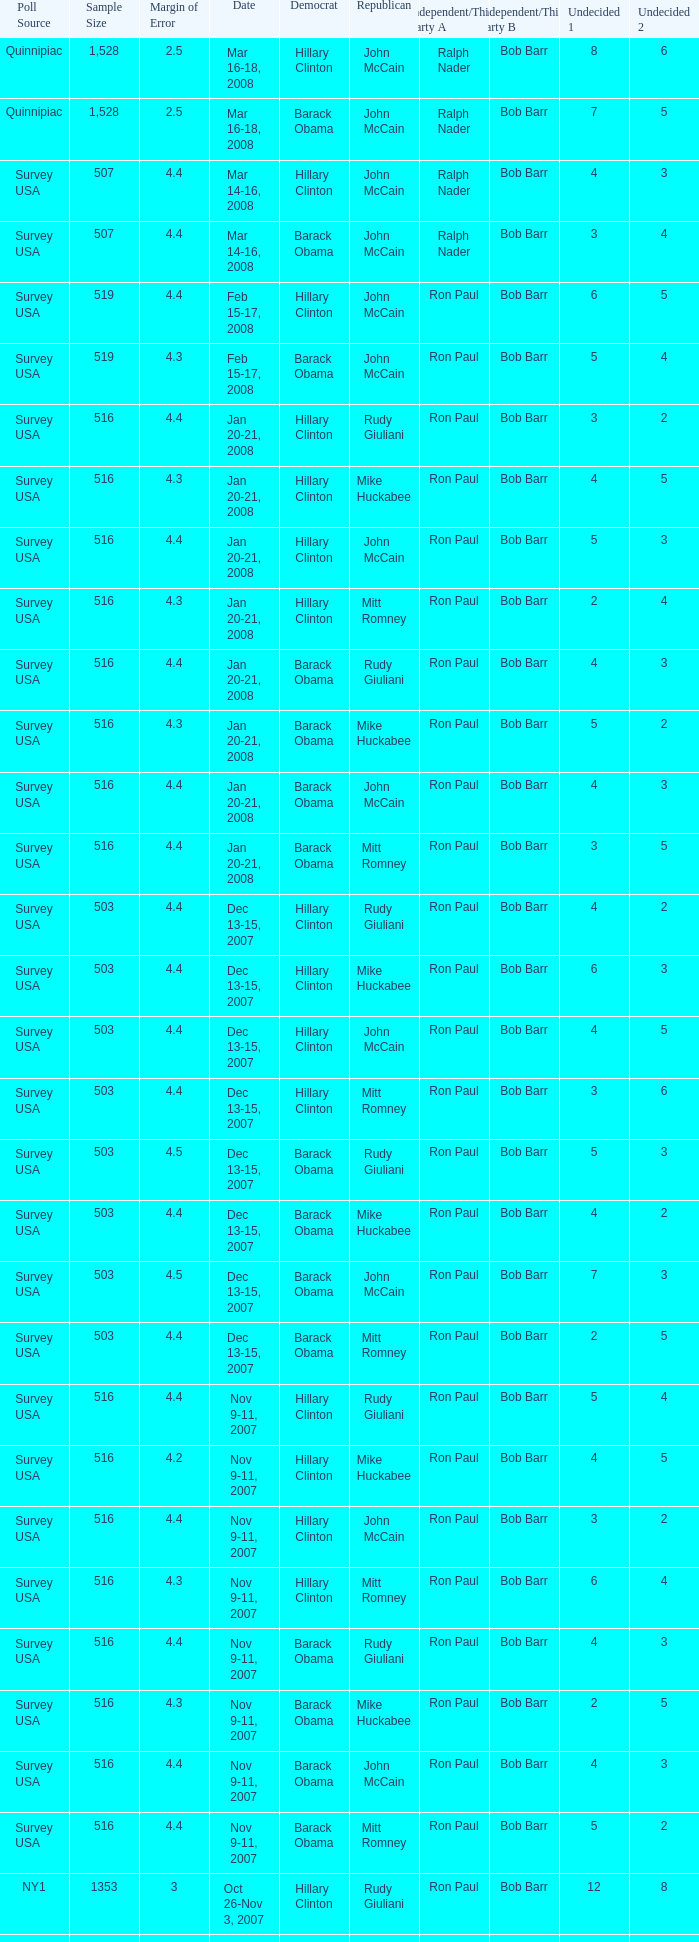Would you be able to parse every entry in this table? {'header': ['Poll Source', 'Sample Size', 'Margin of Error', 'Date', 'Democrat', 'Republican', 'Independent/Third Party A', 'Independent/Third Party B', 'Undecided 1', 'Undecided 2'], 'rows': [['Quinnipiac', '1,528', '2.5', 'Mar 16-18, 2008', 'Hillary Clinton', 'John McCain', 'Ralph Nader', 'Bob Barr', '8', '6'], ['Quinnipiac', '1,528', '2.5', 'Mar 16-18, 2008', 'Barack Obama', 'John McCain', 'Ralph Nader', 'Bob Barr', '7', '5'], ['Survey USA', '507', '4.4', 'Mar 14-16, 2008', 'Hillary Clinton', 'John McCain', 'Ralph Nader', 'Bob Barr', '4', '3'], ['Survey USA', '507', '4.4', 'Mar 14-16, 2008', 'Barack Obama', 'John McCain', 'Ralph Nader', 'Bob Barr', '3', '4'], ['Survey USA', '519', '4.4', 'Feb 15-17, 2008', 'Hillary Clinton', 'John McCain', 'Ron Paul', 'Bob Barr', '6', '5'], ['Survey USA', '519', '4.3', 'Feb 15-17, 2008', 'Barack Obama', 'John McCain', 'Ron Paul', 'Bob Barr', '5', '4'], ['Survey USA', '516', '4.4', 'Jan 20-21, 2008', 'Hillary Clinton', 'Rudy Giuliani', 'Ron Paul', 'Bob Barr', '3', '2'], ['Survey USA', '516', '4.3', 'Jan 20-21, 2008', 'Hillary Clinton', 'Mike Huckabee', 'Ron Paul', 'Bob Barr', '4', '5'], ['Survey USA', '516', '4.4', 'Jan 20-21, 2008', 'Hillary Clinton', 'John McCain', 'Ron Paul', 'Bob Barr', '5', '3'], ['Survey USA', '516', '4.3', 'Jan 20-21, 2008', 'Hillary Clinton', 'Mitt Romney', 'Ron Paul', 'Bob Barr', '2', '4'], ['Survey USA', '516', '4.4', 'Jan 20-21, 2008', 'Barack Obama', 'Rudy Giuliani', 'Ron Paul', 'Bob Barr', '4', '3'], ['Survey USA', '516', '4.3', 'Jan 20-21, 2008', 'Barack Obama', 'Mike Huckabee', 'Ron Paul', 'Bob Barr', '5', '2'], ['Survey USA', '516', '4.4', 'Jan 20-21, 2008', 'Barack Obama', 'John McCain', 'Ron Paul', 'Bob Barr', '4', '3'], ['Survey USA', '516', '4.4', 'Jan 20-21, 2008', 'Barack Obama', 'Mitt Romney', 'Ron Paul', 'Bob Barr', '3', '5'], ['Survey USA', '503', '4.4', 'Dec 13-15, 2007', 'Hillary Clinton', 'Rudy Giuliani', 'Ron Paul', 'Bob Barr', '4', '2'], ['Survey USA', '503', '4.4', 'Dec 13-15, 2007', 'Hillary Clinton', 'Mike Huckabee', 'Ron Paul', 'Bob Barr', '6', '3'], ['Survey USA', '503', '4.4', 'Dec 13-15, 2007', 'Hillary Clinton', 'John McCain', 'Ron Paul', 'Bob Barr', '4', '5'], ['Survey USA', '503', '4.4', 'Dec 13-15, 2007', 'Hillary Clinton', 'Mitt Romney', 'Ron Paul', 'Bob Barr', '3', '6'], ['Survey USA', '503', '4.5', 'Dec 13-15, 2007', 'Barack Obama', 'Rudy Giuliani', 'Ron Paul', 'Bob Barr', '5', '3'], ['Survey USA', '503', '4.4', 'Dec 13-15, 2007', 'Barack Obama', 'Mike Huckabee', 'Ron Paul', 'Bob Barr', '4', '2'], ['Survey USA', '503', '4.5', 'Dec 13-15, 2007', 'Barack Obama', 'John McCain', 'Ron Paul', 'Bob Barr', '7', '3'], ['Survey USA', '503', '4.4', 'Dec 13-15, 2007', 'Barack Obama', 'Mitt Romney', 'Ron Paul', 'Bob Barr', '2', '5'], ['Survey USA', '516', '4.4', 'Nov 9-11, 2007', 'Hillary Clinton', 'Rudy Giuliani', 'Ron Paul', 'Bob Barr', '5', '4'], ['Survey USA', '516', '4.2', 'Nov 9-11, 2007', 'Hillary Clinton', 'Mike Huckabee', 'Ron Paul', 'Bob Barr', '4', '5'], ['Survey USA', '516', '4.4', 'Nov 9-11, 2007', 'Hillary Clinton', 'John McCain', 'Ron Paul', 'Bob Barr', '3', '2'], ['Survey USA', '516', '4.3', 'Nov 9-11, 2007', 'Hillary Clinton', 'Mitt Romney', 'Ron Paul', 'Bob Barr', '6', '4'], ['Survey USA', '516', '4.4', 'Nov 9-11, 2007', 'Barack Obama', 'Rudy Giuliani', 'Ron Paul', 'Bob Barr', '4', '3'], ['Survey USA', '516', '4.3', 'Nov 9-11, 2007', 'Barack Obama', 'Mike Huckabee', 'Ron Paul', 'Bob Barr', '2', '5'], ['Survey USA', '516', '4.4', 'Nov 9-11, 2007', 'Barack Obama', 'John McCain', 'Ron Paul', 'Bob Barr', '4', '3'], ['Survey USA', '516', '4.4', 'Nov 9-11, 2007', 'Barack Obama', 'Mitt Romney', 'Ron Paul', 'Bob Barr', '5', '2'], ['NY1', '1353', '3', 'Oct 26-Nov 3, 2007', 'Hillary Clinton', 'Rudy Giuliani', 'Ron Paul', 'Bob Barr', '12', '8'], ['NY1', '1353', '3', 'Oct 26-Nov 3, 2007', 'Barack Obama', 'Rudy Giuliani', 'Ron Paul', 'Bob Barr', '11', '9'], ['Survey USA', '507', '4.3', 'Oct 12-14, 2007', 'Hillary Clinton', 'Rudy Giuliani', 'Ron Paul', 'Bob Barr', '3', '2'], ['Survey USA', '496', '4', 'Oct 12-14, 2007', 'Hillary Clinton', 'Mike Huckabee', 'Ron Paul', 'Bob Barr', '5', '4'], ['Survey USA', '493', '4.2', 'Oct 12-14, 2007', 'Hillary Clinton', 'John McCain', 'Ron Paul', 'Bob Barr', '7', '2'], ['Survey USA', '482', '4.1', 'Oct 12-14, 2007', 'Hillary Clinton', 'Ron Paul', 'Bob Barr', 'Rudy Giuliani', '5', '2'], ['Survey USA', '502', '4.1', 'Oct 12-14, 2007', 'Hillary Clinton', 'Mitt Romney', 'Ron Paul', 'Bob Barr', '3', '4'], ['Survey USA', '505', '4.1', 'Oct 12-14, 2007', 'Hillary Clinton', 'Fred Thompson', 'Ron Paul', 'Bob Barr', '6', '3'], ['Quinnipiac', '1063', '3', 'Oct 9-15, 2007', 'Hillary Clinton', 'Rudy Giuliani', 'Ron Paul', 'Bob Barr', '8', '5']]} What is the sample size of the poll taken on Dec 13-15, 2007 that had a margin of error of more than 4 and resulted with Republican Mike Huckabee? 503.0. 